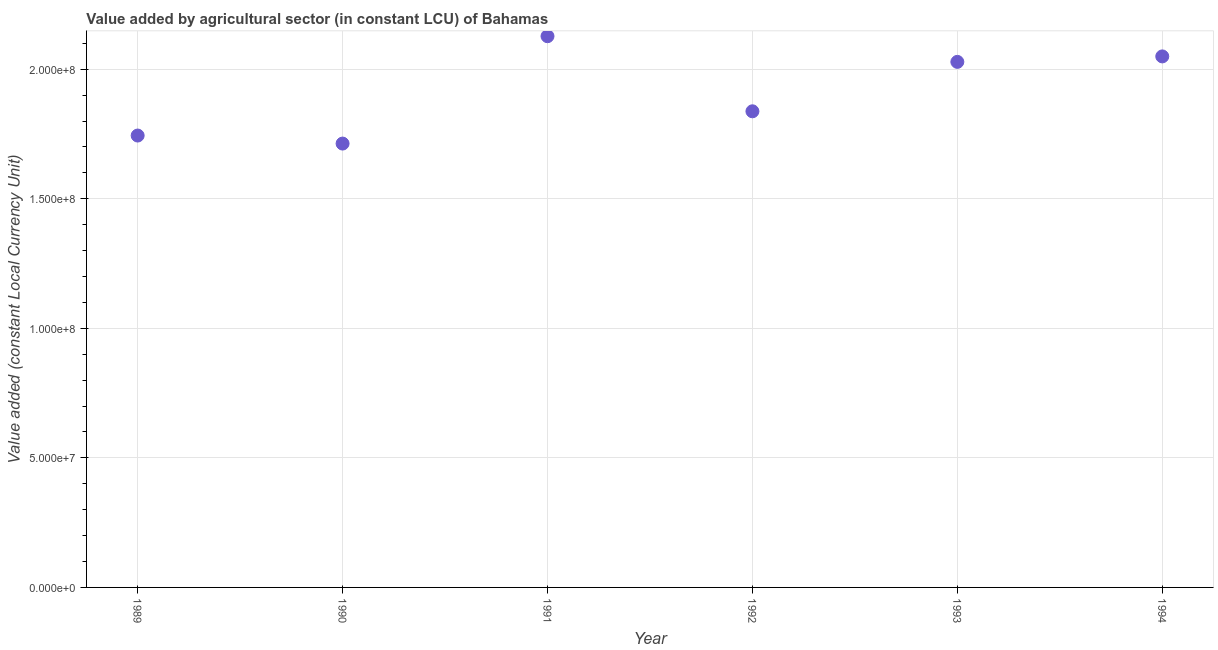What is the value added by agriculture sector in 1992?
Ensure brevity in your answer.  1.84e+08. Across all years, what is the maximum value added by agriculture sector?
Offer a very short reply. 2.13e+08. Across all years, what is the minimum value added by agriculture sector?
Ensure brevity in your answer.  1.71e+08. In which year was the value added by agriculture sector minimum?
Your answer should be very brief. 1990. What is the sum of the value added by agriculture sector?
Make the answer very short. 1.15e+09. What is the difference between the value added by agriculture sector in 1993 and 1994?
Provide a short and direct response. -2.11e+06. What is the average value added by agriculture sector per year?
Provide a succinct answer. 1.92e+08. What is the median value added by agriculture sector?
Provide a succinct answer. 1.93e+08. What is the ratio of the value added by agriculture sector in 1992 to that in 1993?
Provide a short and direct response. 0.91. Is the value added by agriculture sector in 1990 less than that in 1992?
Offer a very short reply. Yes. Is the difference between the value added by agriculture sector in 1992 and 1994 greater than the difference between any two years?
Your answer should be very brief. No. What is the difference between the highest and the second highest value added by agriculture sector?
Provide a succinct answer. 7.80e+06. What is the difference between the highest and the lowest value added by agriculture sector?
Keep it short and to the point. 4.14e+07. Does the graph contain any zero values?
Your answer should be compact. No. Does the graph contain grids?
Your answer should be very brief. Yes. What is the title of the graph?
Offer a terse response. Value added by agricultural sector (in constant LCU) of Bahamas. What is the label or title of the X-axis?
Offer a terse response. Year. What is the label or title of the Y-axis?
Provide a succinct answer. Value added (constant Local Currency Unit). What is the Value added (constant Local Currency Unit) in 1989?
Offer a very short reply. 1.74e+08. What is the Value added (constant Local Currency Unit) in 1990?
Offer a very short reply. 1.71e+08. What is the Value added (constant Local Currency Unit) in 1991?
Keep it short and to the point. 2.13e+08. What is the Value added (constant Local Currency Unit) in 1992?
Ensure brevity in your answer.  1.84e+08. What is the Value added (constant Local Currency Unit) in 1993?
Provide a short and direct response. 2.03e+08. What is the Value added (constant Local Currency Unit) in 1994?
Your answer should be compact. 2.05e+08. What is the difference between the Value added (constant Local Currency Unit) in 1989 and 1990?
Your answer should be compact. 3.10e+06. What is the difference between the Value added (constant Local Currency Unit) in 1989 and 1991?
Ensure brevity in your answer.  -3.83e+07. What is the difference between the Value added (constant Local Currency Unit) in 1989 and 1992?
Your answer should be very brief. -9.36e+06. What is the difference between the Value added (constant Local Currency Unit) in 1989 and 1993?
Your response must be concise. -2.84e+07. What is the difference between the Value added (constant Local Currency Unit) in 1989 and 1994?
Your answer should be very brief. -3.05e+07. What is the difference between the Value added (constant Local Currency Unit) in 1990 and 1991?
Offer a very short reply. -4.14e+07. What is the difference between the Value added (constant Local Currency Unit) in 1990 and 1992?
Provide a short and direct response. -1.25e+07. What is the difference between the Value added (constant Local Currency Unit) in 1990 and 1993?
Ensure brevity in your answer.  -3.15e+07. What is the difference between the Value added (constant Local Currency Unit) in 1990 and 1994?
Your answer should be very brief. -3.36e+07. What is the difference between the Value added (constant Local Currency Unit) in 1991 and 1992?
Make the answer very short. 2.90e+07. What is the difference between the Value added (constant Local Currency Unit) in 1991 and 1993?
Your response must be concise. 9.91e+06. What is the difference between the Value added (constant Local Currency Unit) in 1991 and 1994?
Provide a succinct answer. 7.80e+06. What is the difference between the Value added (constant Local Currency Unit) in 1992 and 1993?
Your response must be concise. -1.91e+07. What is the difference between the Value added (constant Local Currency Unit) in 1992 and 1994?
Give a very brief answer. -2.12e+07. What is the difference between the Value added (constant Local Currency Unit) in 1993 and 1994?
Provide a short and direct response. -2.11e+06. What is the ratio of the Value added (constant Local Currency Unit) in 1989 to that in 1990?
Make the answer very short. 1.02. What is the ratio of the Value added (constant Local Currency Unit) in 1989 to that in 1991?
Your answer should be compact. 0.82. What is the ratio of the Value added (constant Local Currency Unit) in 1989 to that in 1992?
Your response must be concise. 0.95. What is the ratio of the Value added (constant Local Currency Unit) in 1989 to that in 1993?
Offer a terse response. 0.86. What is the ratio of the Value added (constant Local Currency Unit) in 1989 to that in 1994?
Keep it short and to the point. 0.85. What is the ratio of the Value added (constant Local Currency Unit) in 1990 to that in 1991?
Give a very brief answer. 0.81. What is the ratio of the Value added (constant Local Currency Unit) in 1990 to that in 1992?
Offer a very short reply. 0.93. What is the ratio of the Value added (constant Local Currency Unit) in 1990 to that in 1993?
Provide a succinct answer. 0.84. What is the ratio of the Value added (constant Local Currency Unit) in 1990 to that in 1994?
Keep it short and to the point. 0.84. What is the ratio of the Value added (constant Local Currency Unit) in 1991 to that in 1992?
Your response must be concise. 1.16. What is the ratio of the Value added (constant Local Currency Unit) in 1991 to that in 1993?
Provide a succinct answer. 1.05. What is the ratio of the Value added (constant Local Currency Unit) in 1991 to that in 1994?
Offer a very short reply. 1.04. What is the ratio of the Value added (constant Local Currency Unit) in 1992 to that in 1993?
Give a very brief answer. 0.91. What is the ratio of the Value added (constant Local Currency Unit) in 1992 to that in 1994?
Offer a terse response. 0.9. What is the ratio of the Value added (constant Local Currency Unit) in 1993 to that in 1994?
Keep it short and to the point. 0.99. 